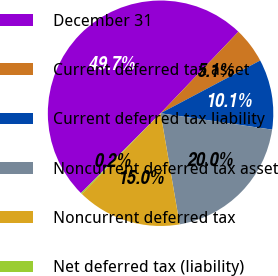<chart> <loc_0><loc_0><loc_500><loc_500><pie_chart><fcel>December 31<fcel>Current deferred tax asset<fcel>Current deferred tax liability<fcel>Noncurrent deferred tax asset<fcel>Noncurrent deferred tax<fcel>Net deferred tax (liability)<nl><fcel>49.65%<fcel>5.12%<fcel>10.07%<fcel>19.97%<fcel>15.02%<fcel>0.17%<nl></chart> 